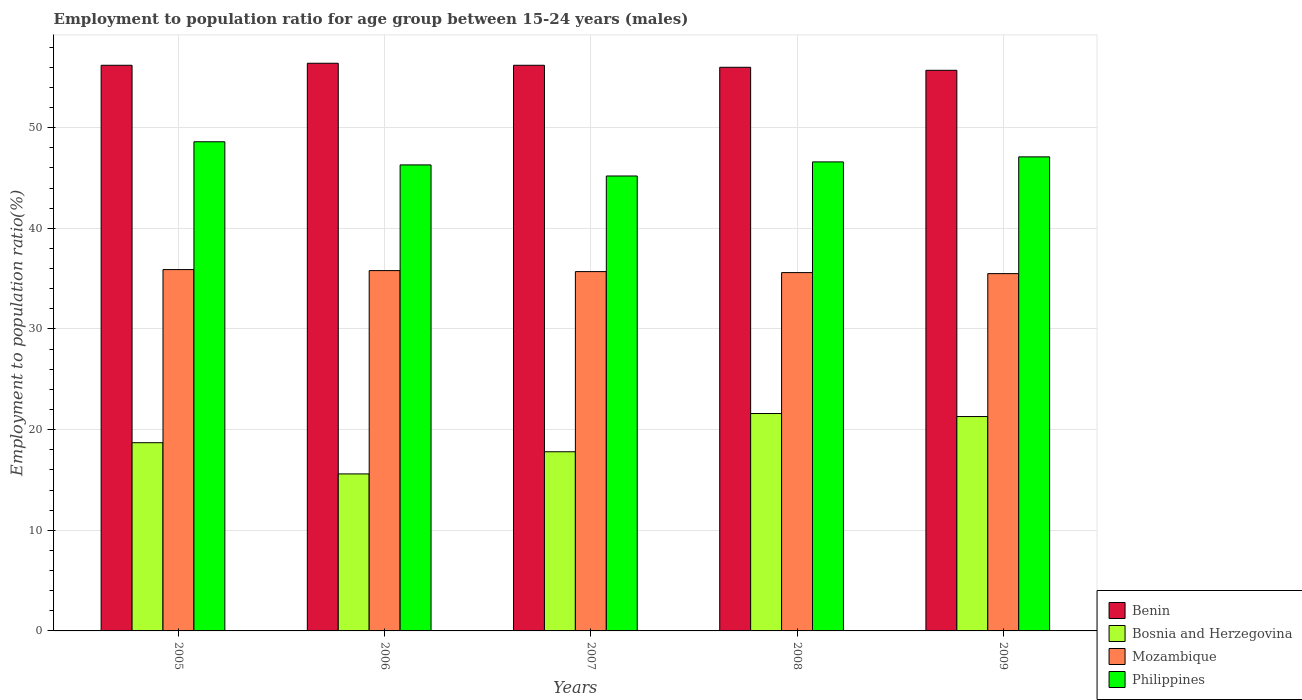How many different coloured bars are there?
Your answer should be compact. 4. Are the number of bars on each tick of the X-axis equal?
Make the answer very short. Yes. How many bars are there on the 1st tick from the left?
Offer a very short reply. 4. How many bars are there on the 1st tick from the right?
Provide a short and direct response. 4. What is the label of the 2nd group of bars from the left?
Provide a short and direct response. 2006. In how many cases, is the number of bars for a given year not equal to the number of legend labels?
Your answer should be very brief. 0. What is the employment to population ratio in Philippines in 2006?
Give a very brief answer. 46.3. Across all years, what is the maximum employment to population ratio in Philippines?
Provide a short and direct response. 48.6. Across all years, what is the minimum employment to population ratio in Philippines?
Your answer should be compact. 45.2. In which year was the employment to population ratio in Mozambique minimum?
Offer a terse response. 2009. What is the total employment to population ratio in Mozambique in the graph?
Offer a very short reply. 178.5. What is the difference between the employment to population ratio in Bosnia and Herzegovina in 2006 and that in 2009?
Ensure brevity in your answer.  -5.7. What is the difference between the employment to population ratio in Mozambique in 2005 and the employment to population ratio in Philippines in 2006?
Ensure brevity in your answer.  -10.4. What is the average employment to population ratio in Mozambique per year?
Offer a terse response. 35.7. In the year 2005, what is the difference between the employment to population ratio in Benin and employment to population ratio in Mozambique?
Offer a terse response. 20.3. What is the ratio of the employment to population ratio in Mozambique in 2006 to that in 2008?
Give a very brief answer. 1.01. What is the difference between the highest and the second highest employment to population ratio in Mozambique?
Your answer should be compact. 0.1. What is the difference between the highest and the lowest employment to population ratio in Mozambique?
Keep it short and to the point. 0.4. Is it the case that in every year, the sum of the employment to population ratio in Philippines and employment to population ratio in Mozambique is greater than the sum of employment to population ratio in Benin and employment to population ratio in Bosnia and Herzegovina?
Offer a very short reply. Yes. What does the 3rd bar from the left in 2007 represents?
Your response must be concise. Mozambique. What does the 4th bar from the right in 2007 represents?
Ensure brevity in your answer.  Benin. Is it the case that in every year, the sum of the employment to population ratio in Mozambique and employment to population ratio in Philippines is greater than the employment to population ratio in Bosnia and Herzegovina?
Ensure brevity in your answer.  Yes. How many years are there in the graph?
Ensure brevity in your answer.  5. Are the values on the major ticks of Y-axis written in scientific E-notation?
Give a very brief answer. No. Does the graph contain any zero values?
Give a very brief answer. No. Does the graph contain grids?
Provide a short and direct response. Yes. How are the legend labels stacked?
Your answer should be very brief. Vertical. What is the title of the graph?
Make the answer very short. Employment to population ratio for age group between 15-24 years (males). What is the label or title of the X-axis?
Offer a very short reply. Years. What is the Employment to population ratio(%) in Benin in 2005?
Make the answer very short. 56.2. What is the Employment to population ratio(%) in Bosnia and Herzegovina in 2005?
Your answer should be compact. 18.7. What is the Employment to population ratio(%) in Mozambique in 2005?
Provide a short and direct response. 35.9. What is the Employment to population ratio(%) of Philippines in 2005?
Your response must be concise. 48.6. What is the Employment to population ratio(%) of Benin in 2006?
Make the answer very short. 56.4. What is the Employment to population ratio(%) in Bosnia and Herzegovina in 2006?
Provide a short and direct response. 15.6. What is the Employment to population ratio(%) in Mozambique in 2006?
Your answer should be very brief. 35.8. What is the Employment to population ratio(%) of Philippines in 2006?
Give a very brief answer. 46.3. What is the Employment to population ratio(%) in Benin in 2007?
Your response must be concise. 56.2. What is the Employment to population ratio(%) in Bosnia and Herzegovina in 2007?
Provide a short and direct response. 17.8. What is the Employment to population ratio(%) in Mozambique in 2007?
Keep it short and to the point. 35.7. What is the Employment to population ratio(%) of Philippines in 2007?
Your answer should be compact. 45.2. What is the Employment to population ratio(%) in Benin in 2008?
Give a very brief answer. 56. What is the Employment to population ratio(%) in Bosnia and Herzegovina in 2008?
Offer a terse response. 21.6. What is the Employment to population ratio(%) in Mozambique in 2008?
Keep it short and to the point. 35.6. What is the Employment to population ratio(%) in Philippines in 2008?
Provide a short and direct response. 46.6. What is the Employment to population ratio(%) of Benin in 2009?
Your answer should be very brief. 55.7. What is the Employment to population ratio(%) of Bosnia and Herzegovina in 2009?
Provide a succinct answer. 21.3. What is the Employment to population ratio(%) in Mozambique in 2009?
Ensure brevity in your answer.  35.5. What is the Employment to population ratio(%) of Philippines in 2009?
Ensure brevity in your answer.  47.1. Across all years, what is the maximum Employment to population ratio(%) in Benin?
Keep it short and to the point. 56.4. Across all years, what is the maximum Employment to population ratio(%) in Bosnia and Herzegovina?
Your response must be concise. 21.6. Across all years, what is the maximum Employment to population ratio(%) in Mozambique?
Offer a terse response. 35.9. Across all years, what is the maximum Employment to population ratio(%) of Philippines?
Your answer should be very brief. 48.6. Across all years, what is the minimum Employment to population ratio(%) of Benin?
Provide a short and direct response. 55.7. Across all years, what is the minimum Employment to population ratio(%) in Bosnia and Herzegovina?
Provide a short and direct response. 15.6. Across all years, what is the minimum Employment to population ratio(%) in Mozambique?
Ensure brevity in your answer.  35.5. Across all years, what is the minimum Employment to population ratio(%) of Philippines?
Offer a terse response. 45.2. What is the total Employment to population ratio(%) in Benin in the graph?
Your answer should be very brief. 280.5. What is the total Employment to population ratio(%) of Bosnia and Herzegovina in the graph?
Ensure brevity in your answer.  95. What is the total Employment to population ratio(%) in Mozambique in the graph?
Ensure brevity in your answer.  178.5. What is the total Employment to population ratio(%) in Philippines in the graph?
Ensure brevity in your answer.  233.8. What is the difference between the Employment to population ratio(%) of Philippines in 2005 and that in 2006?
Your answer should be compact. 2.3. What is the difference between the Employment to population ratio(%) in Benin in 2005 and that in 2007?
Offer a terse response. 0. What is the difference between the Employment to population ratio(%) in Bosnia and Herzegovina in 2005 and that in 2008?
Offer a very short reply. -2.9. What is the difference between the Employment to population ratio(%) in Mozambique in 2005 and that in 2008?
Give a very brief answer. 0.3. What is the difference between the Employment to population ratio(%) of Philippines in 2005 and that in 2008?
Ensure brevity in your answer.  2. What is the difference between the Employment to population ratio(%) of Bosnia and Herzegovina in 2005 and that in 2009?
Provide a succinct answer. -2.6. What is the difference between the Employment to population ratio(%) in Philippines in 2005 and that in 2009?
Make the answer very short. 1.5. What is the difference between the Employment to population ratio(%) of Bosnia and Herzegovina in 2006 and that in 2007?
Keep it short and to the point. -2.2. What is the difference between the Employment to population ratio(%) of Mozambique in 2006 and that in 2007?
Your answer should be compact. 0.1. What is the difference between the Employment to population ratio(%) of Philippines in 2006 and that in 2007?
Offer a terse response. 1.1. What is the difference between the Employment to population ratio(%) in Benin in 2006 and that in 2009?
Provide a succinct answer. 0.7. What is the difference between the Employment to population ratio(%) in Bosnia and Herzegovina in 2006 and that in 2009?
Ensure brevity in your answer.  -5.7. What is the difference between the Employment to population ratio(%) in Mozambique in 2006 and that in 2009?
Your response must be concise. 0.3. What is the difference between the Employment to population ratio(%) in Philippines in 2006 and that in 2009?
Ensure brevity in your answer.  -0.8. What is the difference between the Employment to population ratio(%) of Benin in 2007 and that in 2008?
Provide a succinct answer. 0.2. What is the difference between the Employment to population ratio(%) of Philippines in 2007 and that in 2008?
Keep it short and to the point. -1.4. What is the difference between the Employment to population ratio(%) of Benin in 2007 and that in 2009?
Your answer should be compact. 0.5. What is the difference between the Employment to population ratio(%) in Bosnia and Herzegovina in 2007 and that in 2009?
Provide a succinct answer. -3.5. What is the difference between the Employment to population ratio(%) of Philippines in 2007 and that in 2009?
Offer a very short reply. -1.9. What is the difference between the Employment to population ratio(%) in Benin in 2008 and that in 2009?
Your answer should be compact. 0.3. What is the difference between the Employment to population ratio(%) of Mozambique in 2008 and that in 2009?
Provide a short and direct response. 0.1. What is the difference between the Employment to population ratio(%) in Benin in 2005 and the Employment to population ratio(%) in Bosnia and Herzegovina in 2006?
Ensure brevity in your answer.  40.6. What is the difference between the Employment to population ratio(%) in Benin in 2005 and the Employment to population ratio(%) in Mozambique in 2006?
Your response must be concise. 20.4. What is the difference between the Employment to population ratio(%) in Benin in 2005 and the Employment to population ratio(%) in Philippines in 2006?
Offer a very short reply. 9.9. What is the difference between the Employment to population ratio(%) in Bosnia and Herzegovina in 2005 and the Employment to population ratio(%) in Mozambique in 2006?
Your response must be concise. -17.1. What is the difference between the Employment to population ratio(%) of Bosnia and Herzegovina in 2005 and the Employment to population ratio(%) of Philippines in 2006?
Offer a terse response. -27.6. What is the difference between the Employment to population ratio(%) in Benin in 2005 and the Employment to population ratio(%) in Bosnia and Herzegovina in 2007?
Offer a terse response. 38.4. What is the difference between the Employment to population ratio(%) of Benin in 2005 and the Employment to population ratio(%) of Philippines in 2007?
Make the answer very short. 11. What is the difference between the Employment to population ratio(%) in Bosnia and Herzegovina in 2005 and the Employment to population ratio(%) in Philippines in 2007?
Make the answer very short. -26.5. What is the difference between the Employment to population ratio(%) in Mozambique in 2005 and the Employment to population ratio(%) in Philippines in 2007?
Provide a succinct answer. -9.3. What is the difference between the Employment to population ratio(%) in Benin in 2005 and the Employment to population ratio(%) in Bosnia and Herzegovina in 2008?
Make the answer very short. 34.6. What is the difference between the Employment to population ratio(%) in Benin in 2005 and the Employment to population ratio(%) in Mozambique in 2008?
Offer a very short reply. 20.6. What is the difference between the Employment to population ratio(%) in Bosnia and Herzegovina in 2005 and the Employment to population ratio(%) in Mozambique in 2008?
Make the answer very short. -16.9. What is the difference between the Employment to population ratio(%) of Bosnia and Herzegovina in 2005 and the Employment to population ratio(%) of Philippines in 2008?
Your answer should be compact. -27.9. What is the difference between the Employment to population ratio(%) of Benin in 2005 and the Employment to population ratio(%) of Bosnia and Herzegovina in 2009?
Keep it short and to the point. 34.9. What is the difference between the Employment to population ratio(%) of Benin in 2005 and the Employment to population ratio(%) of Mozambique in 2009?
Keep it short and to the point. 20.7. What is the difference between the Employment to population ratio(%) of Benin in 2005 and the Employment to population ratio(%) of Philippines in 2009?
Make the answer very short. 9.1. What is the difference between the Employment to population ratio(%) in Bosnia and Herzegovina in 2005 and the Employment to population ratio(%) in Mozambique in 2009?
Provide a short and direct response. -16.8. What is the difference between the Employment to population ratio(%) of Bosnia and Herzegovina in 2005 and the Employment to population ratio(%) of Philippines in 2009?
Your answer should be compact. -28.4. What is the difference between the Employment to population ratio(%) of Benin in 2006 and the Employment to population ratio(%) of Bosnia and Herzegovina in 2007?
Keep it short and to the point. 38.6. What is the difference between the Employment to population ratio(%) of Benin in 2006 and the Employment to population ratio(%) of Mozambique in 2007?
Make the answer very short. 20.7. What is the difference between the Employment to population ratio(%) in Bosnia and Herzegovina in 2006 and the Employment to population ratio(%) in Mozambique in 2007?
Offer a terse response. -20.1. What is the difference between the Employment to population ratio(%) of Bosnia and Herzegovina in 2006 and the Employment to population ratio(%) of Philippines in 2007?
Ensure brevity in your answer.  -29.6. What is the difference between the Employment to population ratio(%) of Mozambique in 2006 and the Employment to population ratio(%) of Philippines in 2007?
Offer a terse response. -9.4. What is the difference between the Employment to population ratio(%) of Benin in 2006 and the Employment to population ratio(%) of Bosnia and Herzegovina in 2008?
Your response must be concise. 34.8. What is the difference between the Employment to population ratio(%) of Benin in 2006 and the Employment to population ratio(%) of Mozambique in 2008?
Ensure brevity in your answer.  20.8. What is the difference between the Employment to population ratio(%) of Benin in 2006 and the Employment to population ratio(%) of Philippines in 2008?
Provide a succinct answer. 9.8. What is the difference between the Employment to population ratio(%) of Bosnia and Herzegovina in 2006 and the Employment to population ratio(%) of Mozambique in 2008?
Offer a very short reply. -20. What is the difference between the Employment to population ratio(%) in Bosnia and Herzegovina in 2006 and the Employment to population ratio(%) in Philippines in 2008?
Make the answer very short. -31. What is the difference between the Employment to population ratio(%) of Benin in 2006 and the Employment to population ratio(%) of Bosnia and Herzegovina in 2009?
Your answer should be very brief. 35.1. What is the difference between the Employment to population ratio(%) in Benin in 2006 and the Employment to population ratio(%) in Mozambique in 2009?
Ensure brevity in your answer.  20.9. What is the difference between the Employment to population ratio(%) of Bosnia and Herzegovina in 2006 and the Employment to population ratio(%) of Mozambique in 2009?
Offer a terse response. -19.9. What is the difference between the Employment to population ratio(%) in Bosnia and Herzegovina in 2006 and the Employment to population ratio(%) in Philippines in 2009?
Provide a short and direct response. -31.5. What is the difference between the Employment to population ratio(%) in Mozambique in 2006 and the Employment to population ratio(%) in Philippines in 2009?
Keep it short and to the point. -11.3. What is the difference between the Employment to population ratio(%) of Benin in 2007 and the Employment to population ratio(%) of Bosnia and Herzegovina in 2008?
Keep it short and to the point. 34.6. What is the difference between the Employment to population ratio(%) in Benin in 2007 and the Employment to population ratio(%) in Mozambique in 2008?
Offer a very short reply. 20.6. What is the difference between the Employment to population ratio(%) in Bosnia and Herzegovina in 2007 and the Employment to population ratio(%) in Mozambique in 2008?
Make the answer very short. -17.8. What is the difference between the Employment to population ratio(%) in Bosnia and Herzegovina in 2007 and the Employment to population ratio(%) in Philippines in 2008?
Offer a very short reply. -28.8. What is the difference between the Employment to population ratio(%) in Benin in 2007 and the Employment to population ratio(%) in Bosnia and Herzegovina in 2009?
Offer a very short reply. 34.9. What is the difference between the Employment to population ratio(%) of Benin in 2007 and the Employment to population ratio(%) of Mozambique in 2009?
Give a very brief answer. 20.7. What is the difference between the Employment to population ratio(%) of Bosnia and Herzegovina in 2007 and the Employment to population ratio(%) of Mozambique in 2009?
Provide a succinct answer. -17.7. What is the difference between the Employment to population ratio(%) in Bosnia and Herzegovina in 2007 and the Employment to population ratio(%) in Philippines in 2009?
Your response must be concise. -29.3. What is the difference between the Employment to population ratio(%) in Benin in 2008 and the Employment to population ratio(%) in Bosnia and Herzegovina in 2009?
Your answer should be very brief. 34.7. What is the difference between the Employment to population ratio(%) of Benin in 2008 and the Employment to population ratio(%) of Mozambique in 2009?
Offer a terse response. 20.5. What is the difference between the Employment to population ratio(%) of Bosnia and Herzegovina in 2008 and the Employment to population ratio(%) of Philippines in 2009?
Make the answer very short. -25.5. What is the average Employment to population ratio(%) of Benin per year?
Make the answer very short. 56.1. What is the average Employment to population ratio(%) in Bosnia and Herzegovina per year?
Give a very brief answer. 19. What is the average Employment to population ratio(%) of Mozambique per year?
Offer a very short reply. 35.7. What is the average Employment to population ratio(%) in Philippines per year?
Offer a very short reply. 46.76. In the year 2005, what is the difference between the Employment to population ratio(%) in Benin and Employment to population ratio(%) in Bosnia and Herzegovina?
Keep it short and to the point. 37.5. In the year 2005, what is the difference between the Employment to population ratio(%) of Benin and Employment to population ratio(%) of Mozambique?
Offer a terse response. 20.3. In the year 2005, what is the difference between the Employment to population ratio(%) of Benin and Employment to population ratio(%) of Philippines?
Your response must be concise. 7.6. In the year 2005, what is the difference between the Employment to population ratio(%) in Bosnia and Herzegovina and Employment to population ratio(%) in Mozambique?
Offer a terse response. -17.2. In the year 2005, what is the difference between the Employment to population ratio(%) in Bosnia and Herzegovina and Employment to population ratio(%) in Philippines?
Give a very brief answer. -29.9. In the year 2006, what is the difference between the Employment to population ratio(%) of Benin and Employment to population ratio(%) of Bosnia and Herzegovina?
Your answer should be very brief. 40.8. In the year 2006, what is the difference between the Employment to population ratio(%) of Benin and Employment to population ratio(%) of Mozambique?
Keep it short and to the point. 20.6. In the year 2006, what is the difference between the Employment to population ratio(%) of Benin and Employment to population ratio(%) of Philippines?
Your response must be concise. 10.1. In the year 2006, what is the difference between the Employment to population ratio(%) of Bosnia and Herzegovina and Employment to population ratio(%) of Mozambique?
Ensure brevity in your answer.  -20.2. In the year 2006, what is the difference between the Employment to population ratio(%) of Bosnia and Herzegovina and Employment to population ratio(%) of Philippines?
Your answer should be very brief. -30.7. In the year 2006, what is the difference between the Employment to population ratio(%) of Mozambique and Employment to population ratio(%) of Philippines?
Your answer should be compact. -10.5. In the year 2007, what is the difference between the Employment to population ratio(%) in Benin and Employment to population ratio(%) in Bosnia and Herzegovina?
Offer a very short reply. 38.4. In the year 2007, what is the difference between the Employment to population ratio(%) of Benin and Employment to population ratio(%) of Mozambique?
Provide a short and direct response. 20.5. In the year 2007, what is the difference between the Employment to population ratio(%) in Benin and Employment to population ratio(%) in Philippines?
Offer a terse response. 11. In the year 2007, what is the difference between the Employment to population ratio(%) in Bosnia and Herzegovina and Employment to population ratio(%) in Mozambique?
Provide a succinct answer. -17.9. In the year 2007, what is the difference between the Employment to population ratio(%) of Bosnia and Herzegovina and Employment to population ratio(%) of Philippines?
Keep it short and to the point. -27.4. In the year 2008, what is the difference between the Employment to population ratio(%) of Benin and Employment to population ratio(%) of Bosnia and Herzegovina?
Provide a short and direct response. 34.4. In the year 2008, what is the difference between the Employment to population ratio(%) in Benin and Employment to population ratio(%) in Mozambique?
Keep it short and to the point. 20.4. In the year 2008, what is the difference between the Employment to population ratio(%) in Bosnia and Herzegovina and Employment to population ratio(%) in Philippines?
Make the answer very short. -25. In the year 2009, what is the difference between the Employment to population ratio(%) of Benin and Employment to population ratio(%) of Bosnia and Herzegovina?
Provide a short and direct response. 34.4. In the year 2009, what is the difference between the Employment to population ratio(%) in Benin and Employment to population ratio(%) in Mozambique?
Offer a very short reply. 20.2. In the year 2009, what is the difference between the Employment to population ratio(%) in Bosnia and Herzegovina and Employment to population ratio(%) in Philippines?
Provide a short and direct response. -25.8. In the year 2009, what is the difference between the Employment to population ratio(%) in Mozambique and Employment to population ratio(%) in Philippines?
Offer a very short reply. -11.6. What is the ratio of the Employment to population ratio(%) of Benin in 2005 to that in 2006?
Keep it short and to the point. 1. What is the ratio of the Employment to population ratio(%) in Bosnia and Herzegovina in 2005 to that in 2006?
Make the answer very short. 1.2. What is the ratio of the Employment to population ratio(%) of Philippines in 2005 to that in 2006?
Provide a succinct answer. 1.05. What is the ratio of the Employment to population ratio(%) of Bosnia and Herzegovina in 2005 to that in 2007?
Your answer should be very brief. 1.05. What is the ratio of the Employment to population ratio(%) in Mozambique in 2005 to that in 2007?
Your answer should be very brief. 1.01. What is the ratio of the Employment to population ratio(%) in Philippines in 2005 to that in 2007?
Make the answer very short. 1.08. What is the ratio of the Employment to population ratio(%) in Benin in 2005 to that in 2008?
Keep it short and to the point. 1. What is the ratio of the Employment to population ratio(%) of Bosnia and Herzegovina in 2005 to that in 2008?
Provide a succinct answer. 0.87. What is the ratio of the Employment to population ratio(%) of Mozambique in 2005 to that in 2008?
Provide a short and direct response. 1.01. What is the ratio of the Employment to population ratio(%) in Philippines in 2005 to that in 2008?
Your response must be concise. 1.04. What is the ratio of the Employment to population ratio(%) of Bosnia and Herzegovina in 2005 to that in 2009?
Ensure brevity in your answer.  0.88. What is the ratio of the Employment to population ratio(%) in Mozambique in 2005 to that in 2009?
Keep it short and to the point. 1.01. What is the ratio of the Employment to population ratio(%) in Philippines in 2005 to that in 2009?
Offer a very short reply. 1.03. What is the ratio of the Employment to population ratio(%) in Benin in 2006 to that in 2007?
Ensure brevity in your answer.  1. What is the ratio of the Employment to population ratio(%) in Bosnia and Herzegovina in 2006 to that in 2007?
Your response must be concise. 0.88. What is the ratio of the Employment to population ratio(%) of Mozambique in 2006 to that in 2007?
Your response must be concise. 1. What is the ratio of the Employment to population ratio(%) in Philippines in 2006 to that in 2007?
Ensure brevity in your answer.  1.02. What is the ratio of the Employment to population ratio(%) of Benin in 2006 to that in 2008?
Offer a very short reply. 1.01. What is the ratio of the Employment to population ratio(%) in Bosnia and Herzegovina in 2006 to that in 2008?
Your response must be concise. 0.72. What is the ratio of the Employment to population ratio(%) in Mozambique in 2006 to that in 2008?
Offer a terse response. 1.01. What is the ratio of the Employment to population ratio(%) of Philippines in 2006 to that in 2008?
Your response must be concise. 0.99. What is the ratio of the Employment to population ratio(%) in Benin in 2006 to that in 2009?
Your answer should be compact. 1.01. What is the ratio of the Employment to population ratio(%) in Bosnia and Herzegovina in 2006 to that in 2009?
Offer a terse response. 0.73. What is the ratio of the Employment to population ratio(%) in Mozambique in 2006 to that in 2009?
Make the answer very short. 1.01. What is the ratio of the Employment to population ratio(%) in Benin in 2007 to that in 2008?
Your answer should be very brief. 1. What is the ratio of the Employment to population ratio(%) in Bosnia and Herzegovina in 2007 to that in 2008?
Provide a succinct answer. 0.82. What is the ratio of the Employment to population ratio(%) of Benin in 2007 to that in 2009?
Your answer should be very brief. 1.01. What is the ratio of the Employment to population ratio(%) in Bosnia and Herzegovina in 2007 to that in 2009?
Your response must be concise. 0.84. What is the ratio of the Employment to population ratio(%) of Mozambique in 2007 to that in 2009?
Provide a succinct answer. 1.01. What is the ratio of the Employment to population ratio(%) in Philippines in 2007 to that in 2009?
Offer a terse response. 0.96. What is the ratio of the Employment to population ratio(%) in Benin in 2008 to that in 2009?
Keep it short and to the point. 1.01. What is the ratio of the Employment to population ratio(%) of Bosnia and Herzegovina in 2008 to that in 2009?
Give a very brief answer. 1.01. What is the ratio of the Employment to population ratio(%) in Mozambique in 2008 to that in 2009?
Keep it short and to the point. 1. What is the difference between the highest and the second highest Employment to population ratio(%) in Bosnia and Herzegovina?
Offer a terse response. 0.3. What is the difference between the highest and the second highest Employment to population ratio(%) of Mozambique?
Provide a succinct answer. 0.1. What is the difference between the highest and the lowest Employment to population ratio(%) of Benin?
Offer a terse response. 0.7. What is the difference between the highest and the lowest Employment to population ratio(%) of Bosnia and Herzegovina?
Give a very brief answer. 6. What is the difference between the highest and the lowest Employment to population ratio(%) of Mozambique?
Offer a very short reply. 0.4. What is the difference between the highest and the lowest Employment to population ratio(%) in Philippines?
Provide a short and direct response. 3.4. 